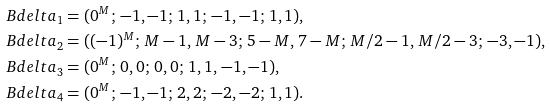Convert formula to latex. <formula><loc_0><loc_0><loc_500><loc_500>\ B d e l t a _ { 1 } & = ( 0 ^ { M } ; \, - 1 , - 1 ; \, 1 , 1 ; \, - 1 , - 1 ; \, 1 , 1 ) , \\ \ B d e l t a _ { 2 } & = ( ( - 1 ) ^ { M } ; \, M - 1 , \, M - 3 ; \, 5 - M , \, 7 - M ; \, M / 2 - 1 , \, M / 2 - 3 ; \, - 3 , - 1 ) , \\ \ B d e l t a _ { 3 } & = ( 0 ^ { M } ; \, 0 , 0 ; \, 0 , 0 ; \, 1 , 1 , \, - 1 , - 1 ) , \\ \ B d e l t a _ { 4 } & = ( 0 ^ { M } ; \, - 1 , - 1 ; \, 2 , 2 ; \, - 2 , - 2 ; \, 1 , 1 ) .</formula> 